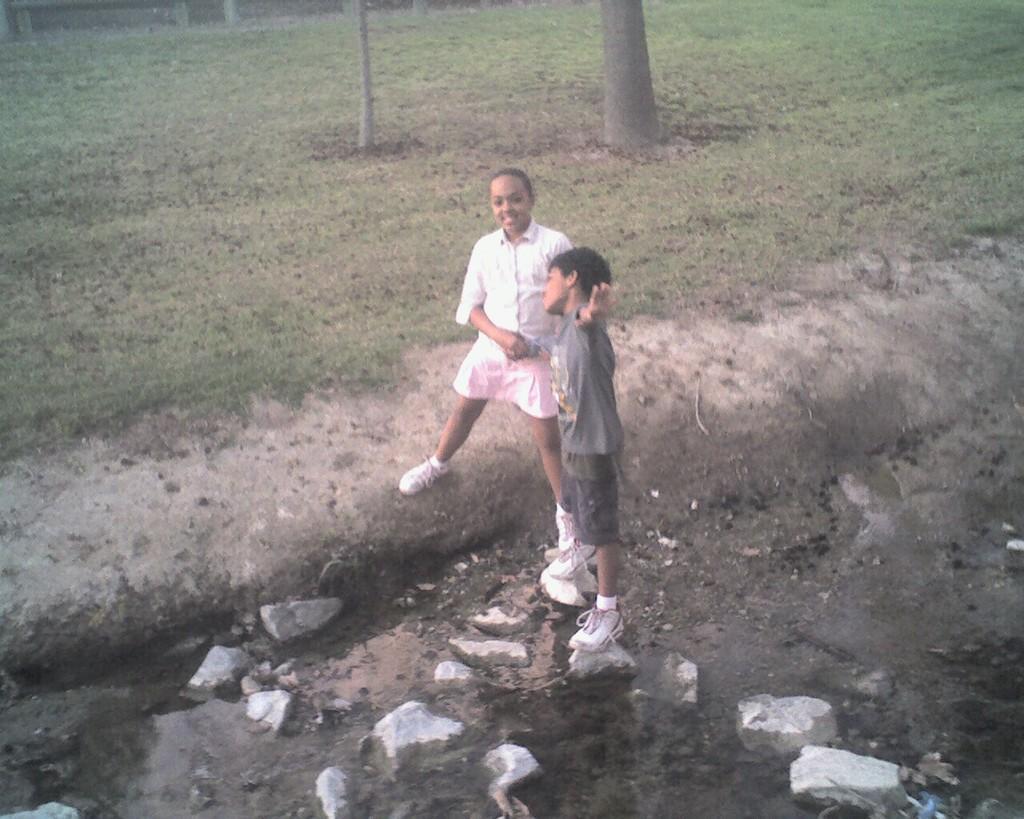Could you give a brief overview of what you see in this image? In this image, I can see two persons standing. At the bottom of the image, there are rocks. In the background, I can see the tree trunks and grass. 